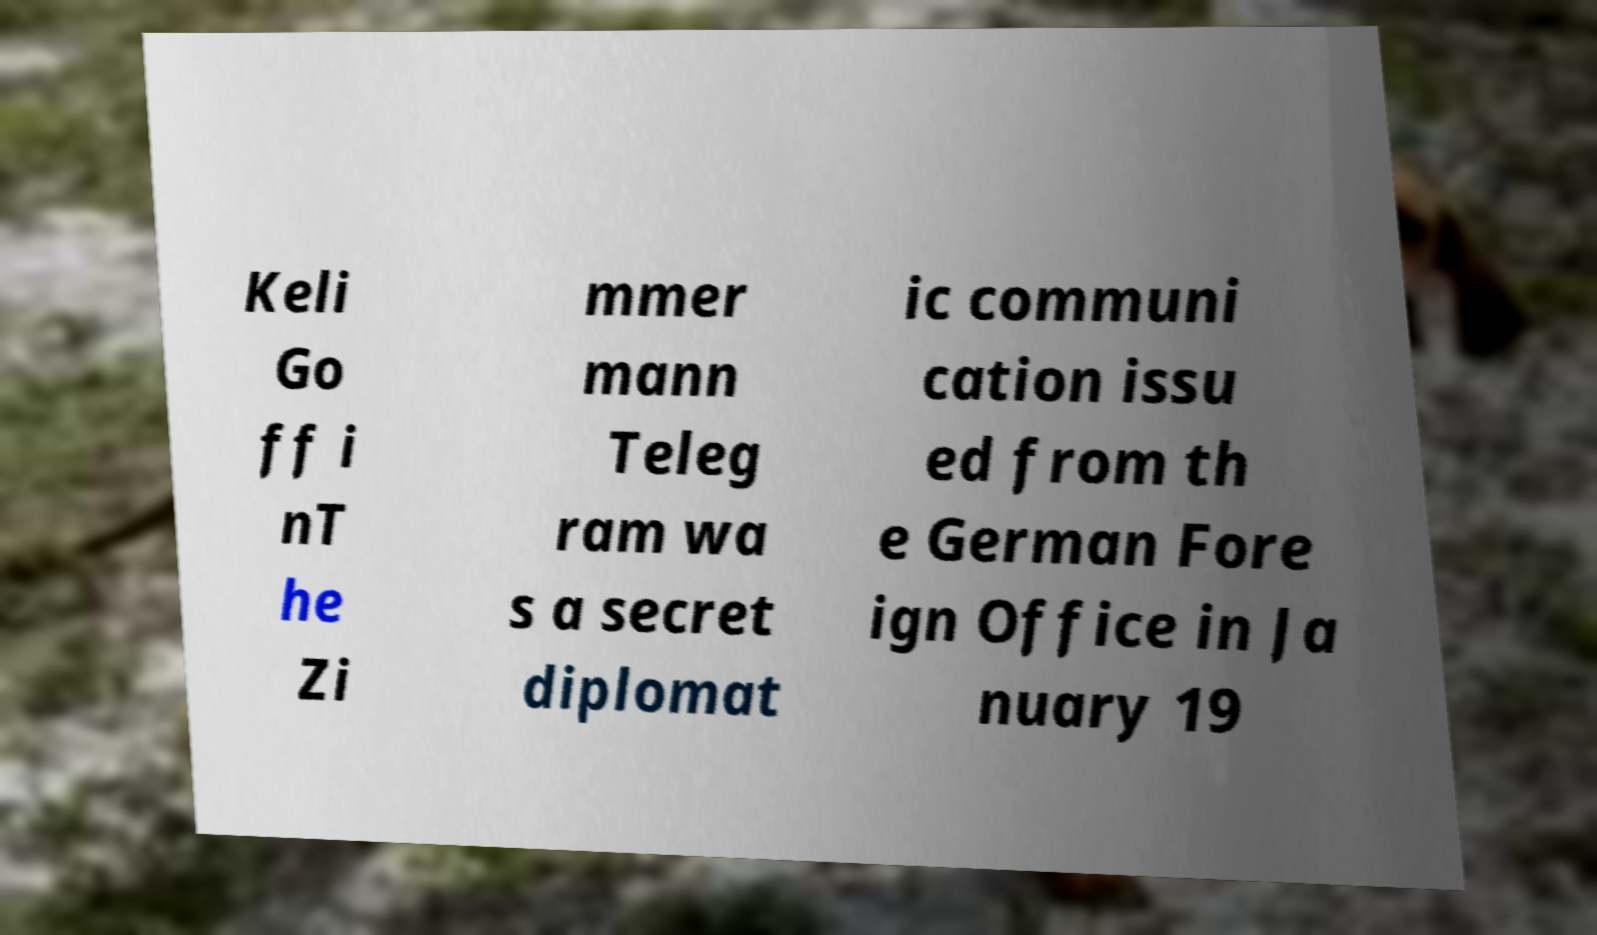Could you extract and type out the text from this image? Keli Go ff i nT he Zi mmer mann Teleg ram wa s a secret diplomat ic communi cation issu ed from th e German Fore ign Office in Ja nuary 19 